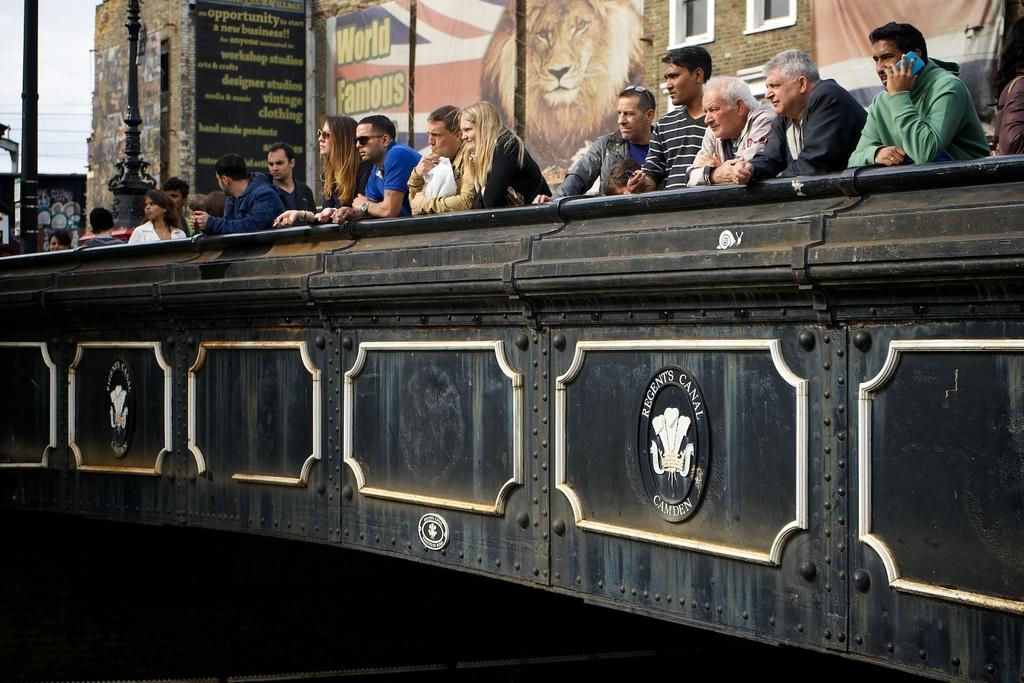<image>
Offer a succinct explanation of the picture presented. People are looking out over a bridge that says Regent Canal Camden. 